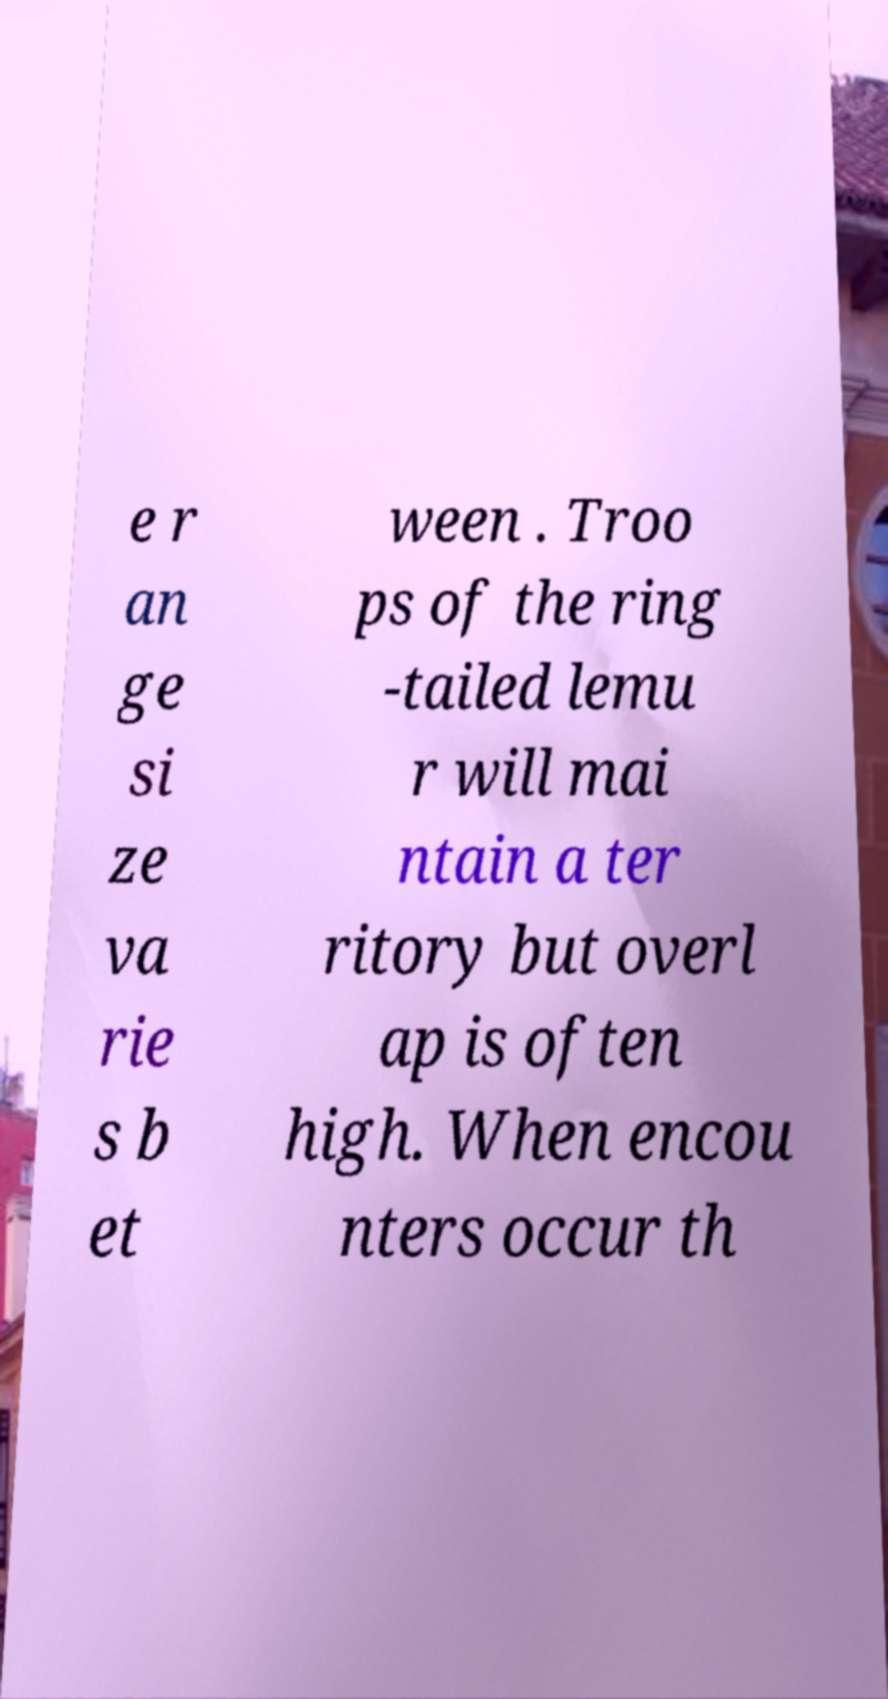Could you extract and type out the text from this image? e r an ge si ze va rie s b et ween . Troo ps of the ring -tailed lemu r will mai ntain a ter ritory but overl ap is often high. When encou nters occur th 